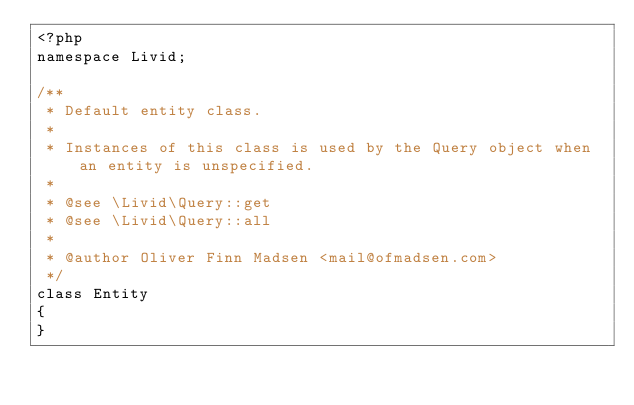Convert code to text. <code><loc_0><loc_0><loc_500><loc_500><_PHP_><?php
namespace Livid;

/**
 * Default entity class.
 *
 * Instances of this class is used by the Query object when an entity is unspecified.
 *
 * @see \Livid\Query::get
 * @see \Livid\Query::all
 *
 * @author Oliver Finn Madsen <mail@ofmadsen.com>
 */
class Entity
{
}
</code> 